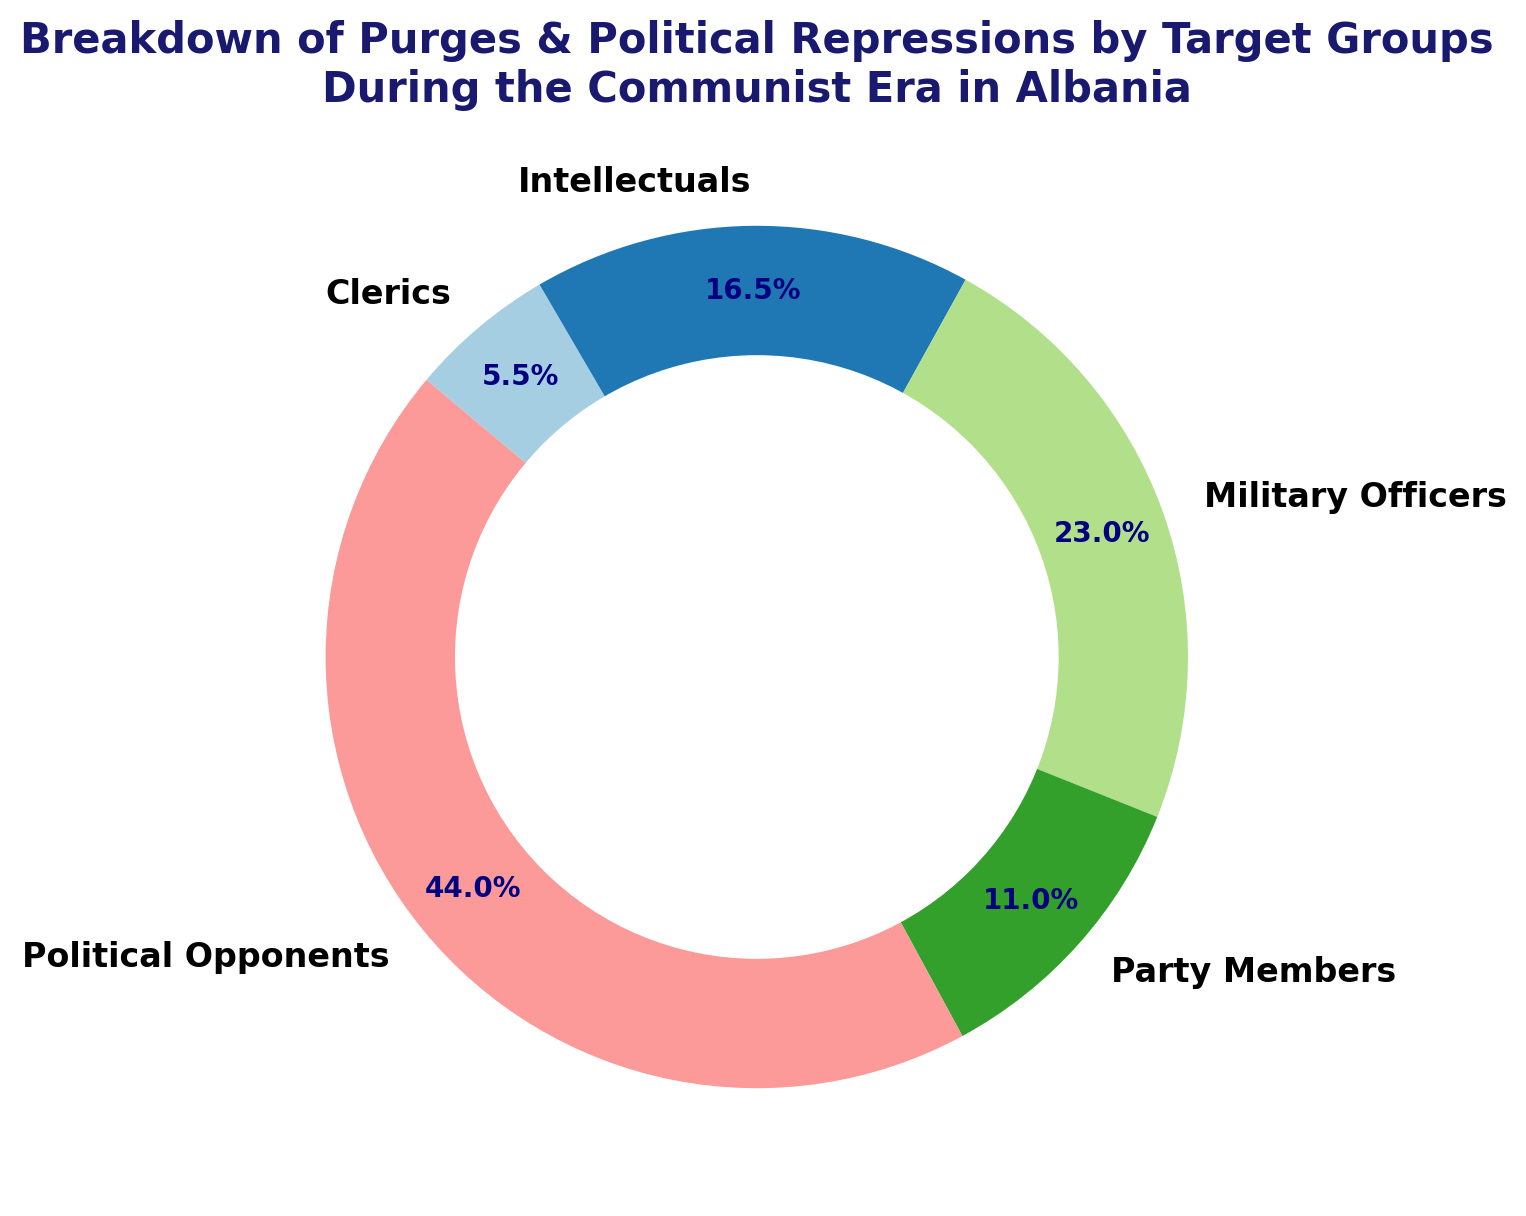Which target group experienced the highest percentage of purges? To find which target group experienced the highest percentage of purges, we identify the segment in the ring chart covering the largest area and check its label.
Answer: Political Opponents What percentage of purges were directed at political opponents? We look for the percentage label associated with the 'Political Opponents' segment in the ring chart.
Answer: 44.9% How do the purges of intellectuals compare to those of clerics in percentage terms? We examine the percentage labels for both 'Intellectuals' and 'Clerics' segments and compare their values.
Answer: Intellectuals experienced more purges, with 18.4%, while Clerics had 7.6% What is the combined percentage of purges directed at military officers and party members? We add the percentage values of the 'Military Officers' (14.6%) and 'Party Members' (9.2%) segments.
Answer: 23.8% What visual feature indicates the group with fewer purges between clerics and party members? The group with fewer purges will have a smaller segment in the ring chart. By comparing the areas, we can see which is smaller.
Answer: Clerics Considering intellectuals and political opponents, how many more percentage points do political opponents account for? Subtract the percentage of 'Intellectuals' (18.4%) from 'Political Opponents' (44.9%).
Answer: 26.5% Which segment is represented by the smallest percentage, and what is that percentage? Identify the smallest segment in the ring chart and check its percentage label.
Answer: Clerics, 7.6% What is the visual difference between the segments for military officers and intellectuals in terms of percentage sizes? Compare the areas representing 'Military Officers' (14.6%) and 'Intellectuals' (18.4%) in the ring chart.
Answer: Intellectuals' segment is larger by 3.8 percentage points How does the percentage of purges for party members compare to military officers? Compare the percentage values of the 'Party Members' (9.2%) and 'Military Officers' (14.6%) segments.
Answer: Military officers experienced a higher percentage by 5.4 points Summing the percentages of purges for intellectuals and clerics, what is the total? Add the percentages for 'Intellectuals' (18.4%) and 'Clerics' (7.6%).
Answer: 26% 